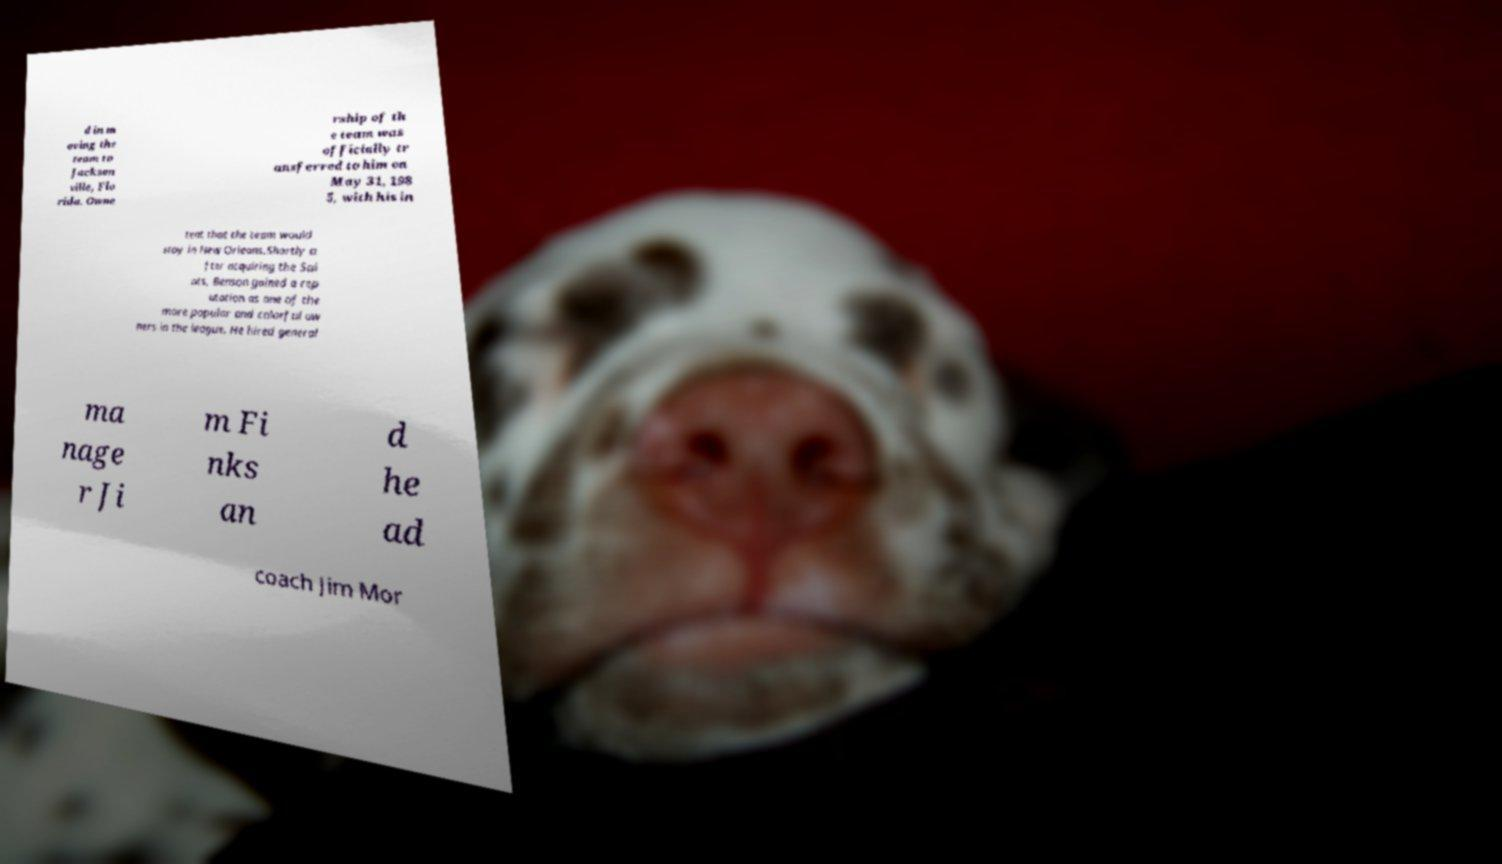Can you accurately transcribe the text from the provided image for me? d in m oving the team to Jackson ville, Flo rida. Owne rship of th e team was officially tr ansferred to him on May 31, 198 5, with his in tent that the team would stay in New Orleans.Shortly a fter acquiring the Sai nts, Benson gained a rep utation as one of the more popular and colorful ow ners in the league. He hired general ma nage r Ji m Fi nks an d he ad coach Jim Mor 